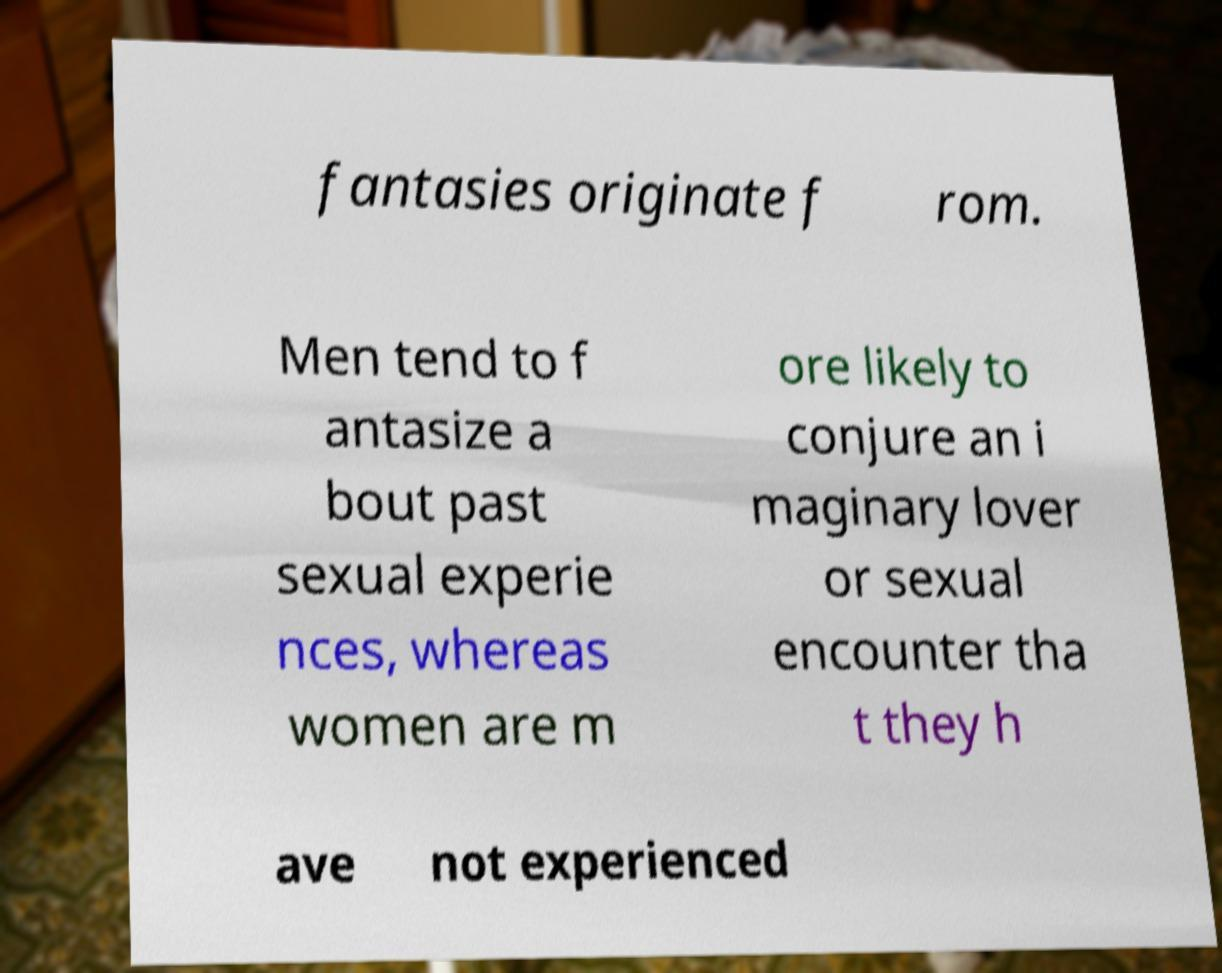Please identify and transcribe the text found in this image. fantasies originate f rom. Men tend to f antasize a bout past sexual experie nces, whereas women are m ore likely to conjure an i maginary lover or sexual encounter tha t they h ave not experienced 